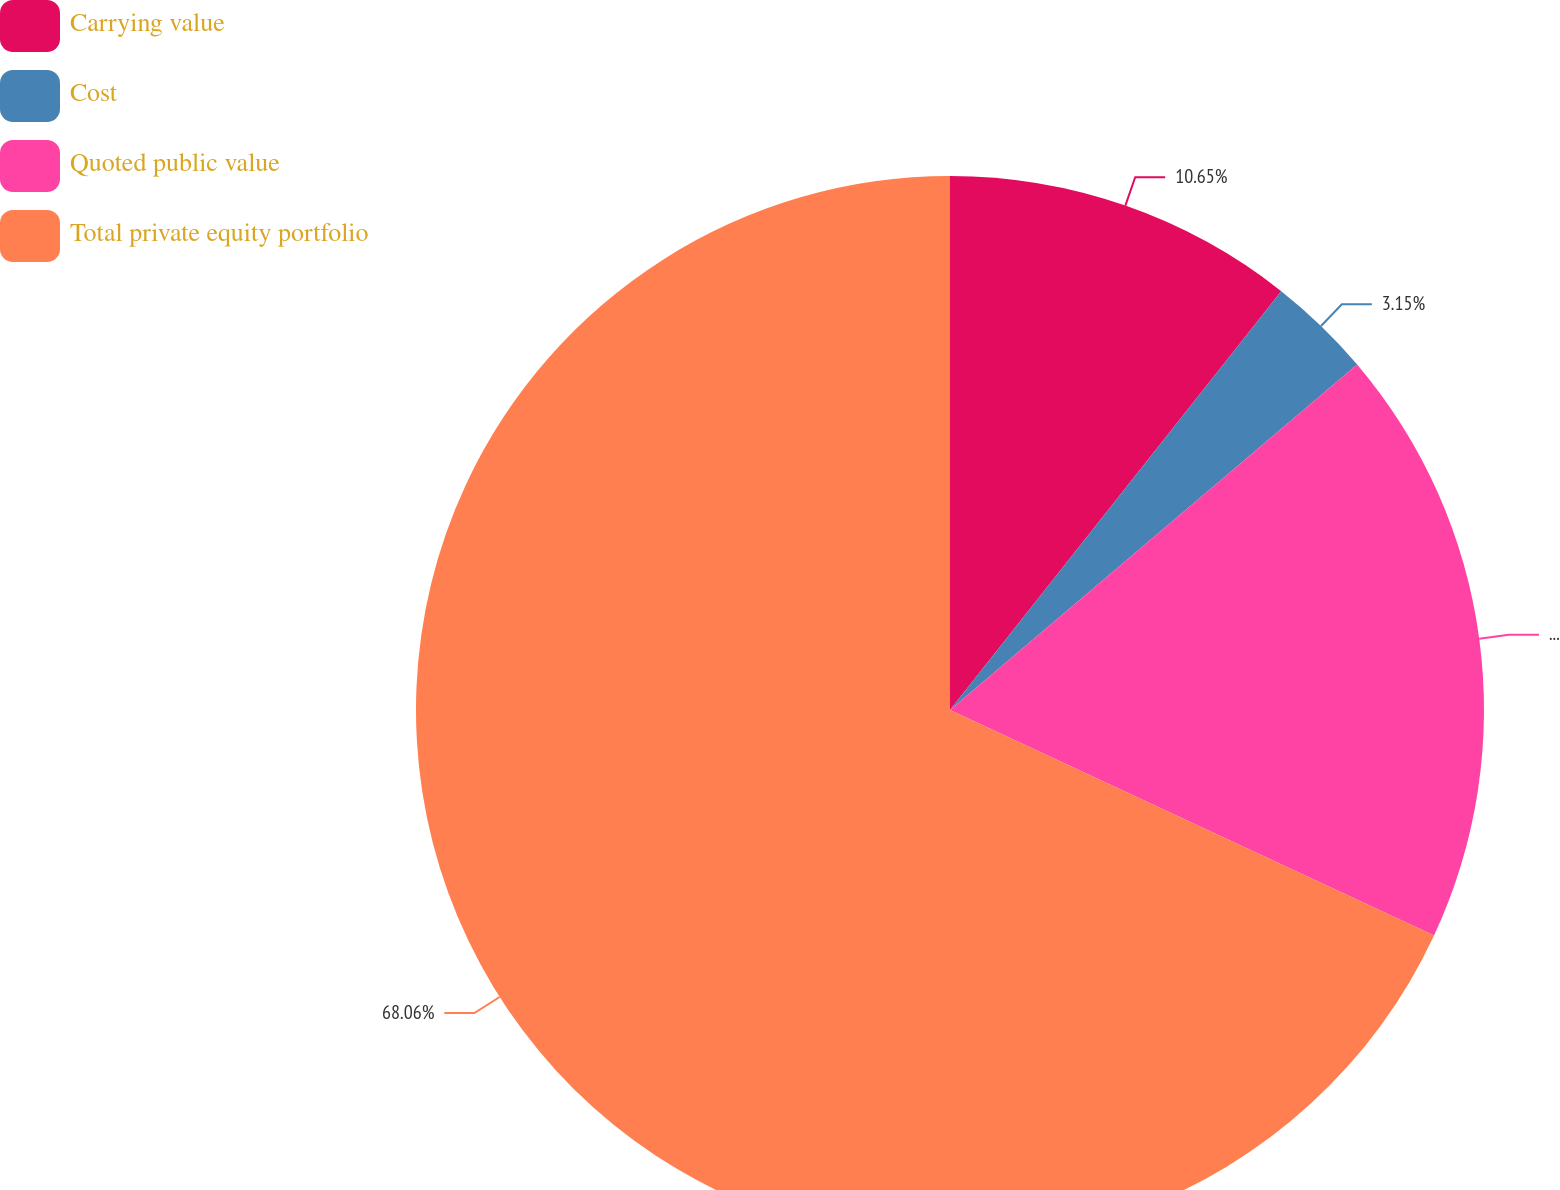<chart> <loc_0><loc_0><loc_500><loc_500><pie_chart><fcel>Carrying value<fcel>Cost<fcel>Quoted public value<fcel>Total private equity portfolio<nl><fcel>10.65%<fcel>3.15%<fcel>18.14%<fcel>68.06%<nl></chart> 